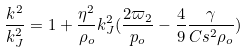<formula> <loc_0><loc_0><loc_500><loc_500>\frac { k ^ { 2 } } { k _ { J } ^ { 2 } } = 1 + \frac { \eta ^ { 2 } } { \rho _ { o } } k _ { J } ^ { 2 } ( \frac { 2 \varpi _ { 2 } } { p _ { o } } - \frac { 4 } { 9 } \frac { \gamma } { C s ^ { 2 } \rho _ { o } } )</formula> 